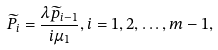<formula> <loc_0><loc_0><loc_500><loc_500>\widetilde { P } _ { i } = \frac { \lambda \widetilde { p } _ { i - 1 } } { i \mu _ { 1 } } , i = 1 , 2 , \dots , m - 1 ,</formula> 